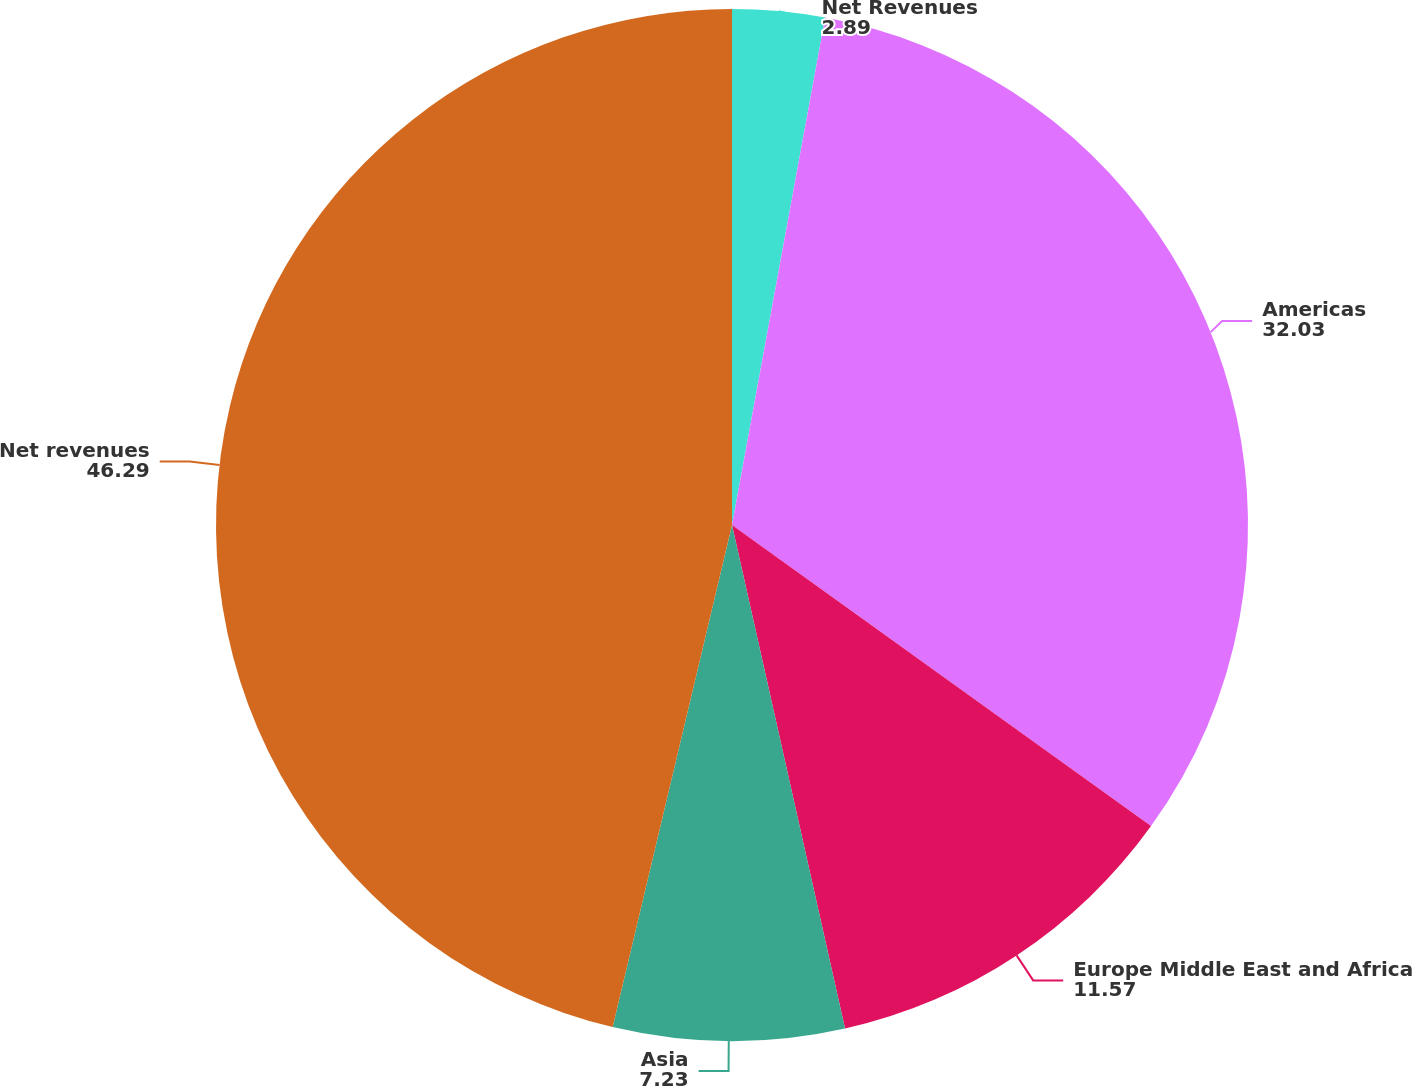Convert chart. <chart><loc_0><loc_0><loc_500><loc_500><pie_chart><fcel>Net Revenues<fcel>Americas<fcel>Europe Middle East and Africa<fcel>Asia<fcel>Net revenues<nl><fcel>2.89%<fcel>32.03%<fcel>11.57%<fcel>7.23%<fcel>46.29%<nl></chart> 